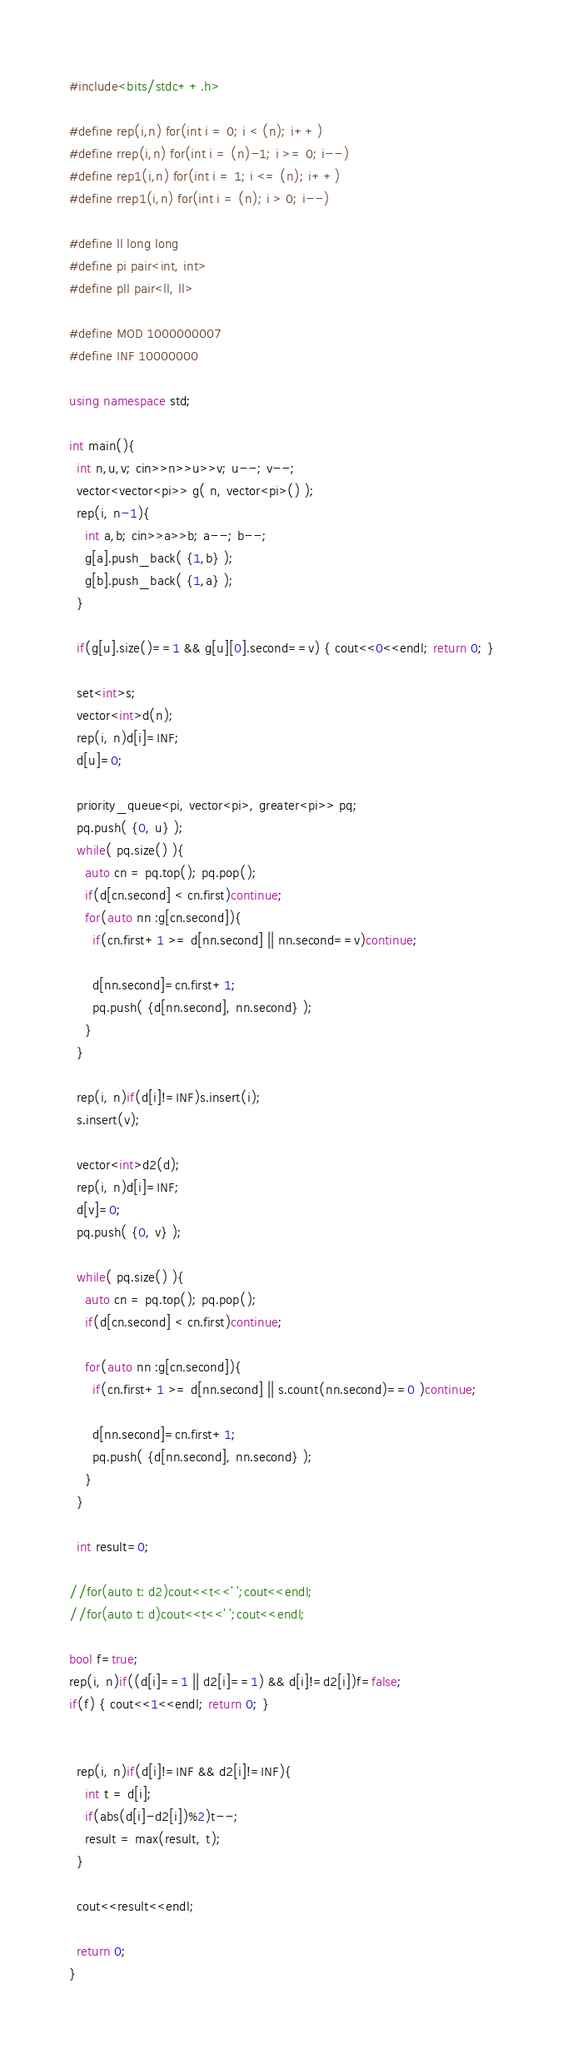Convert code to text. <code><loc_0><loc_0><loc_500><loc_500><_C++_>#include<bits/stdc++.h>

#define rep(i,n) for(int i = 0; i < (n); i++)
#define rrep(i,n) for(int i = (n)-1; i >= 0; i--)
#define rep1(i,n) for(int i = 1; i <= (n); i++)
#define rrep1(i,n) for(int i = (n); i > 0; i--)

#define ll long long
#define pi pair<int, int>
#define pll pair<ll, ll>

#define MOD 1000000007
#define INF 10000000

using namespace std;

int main(){
  int n,u,v; cin>>n>>u>>v; u--; v--;
  vector<vector<pi>> g( n, vector<pi>() );
  rep(i, n-1){
    int a,b; cin>>a>>b; a--; b--;
    g[a].push_back( {1,b} );
    g[b].push_back( {1,a} );
  }

  if(g[u].size()==1 && g[u][0].second==v) { cout<<0<<endl; return 0; }

  set<int>s;
  vector<int>d(n);
  rep(i, n)d[i]=INF; 
  d[u]=0;

  priority_queue<pi, vector<pi>, greater<pi>> pq;
  pq.push( {0, u} );
  while( pq.size() ){
    auto cn = pq.top(); pq.pop();
    if(d[cn.second] < cn.first)continue;
    for(auto nn :g[cn.second]){
      if(cn.first+1 >= d[nn.second] || nn.second==v)continue;

      d[nn.second]=cn.first+1;
      pq.push( {d[nn.second], nn.second} );
    }
  }

  rep(i, n)if(d[i]!=INF)s.insert(i);
  s.insert(v);

  vector<int>d2(d);
  rep(i, n)d[i]=INF; 
  d[v]=0;
  pq.push( {0, v} );
 
  while( pq.size() ){
    auto cn = pq.top(); pq.pop();
    if(d[cn.second] < cn.first)continue;

    for(auto nn :g[cn.second]){
      if(cn.first+1 >= d[nn.second] || s.count(nn.second)==0 )continue;

      d[nn.second]=cn.first+1;
      pq.push( {d[nn.second], nn.second} );
    }
  }

  int result=0;

//for(auto t: d2)cout<<t<<' ';cout<<endl;
//for(auto t: d)cout<<t<<' ';cout<<endl;

bool f=true;
rep(i, n)if((d[i]==1 || d2[i]==1) && d[i]!=d2[i])f=false;
if(f) { cout<<1<<endl; return 0; }


  rep(i, n)if(d[i]!=INF && d2[i]!=INF){
    int t = d[i];
    if(abs(d[i]-d2[i])%2)t--;
    result = max(result, t);
  }

  cout<<result<<endl;

  return 0;
}</code> 